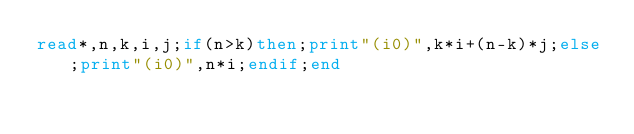<code> <loc_0><loc_0><loc_500><loc_500><_FORTRAN_>read*,n,k,i,j;if(n>k)then;print"(i0)",k*i+(n-k)*j;else;print"(i0)",n*i;endif;end</code> 